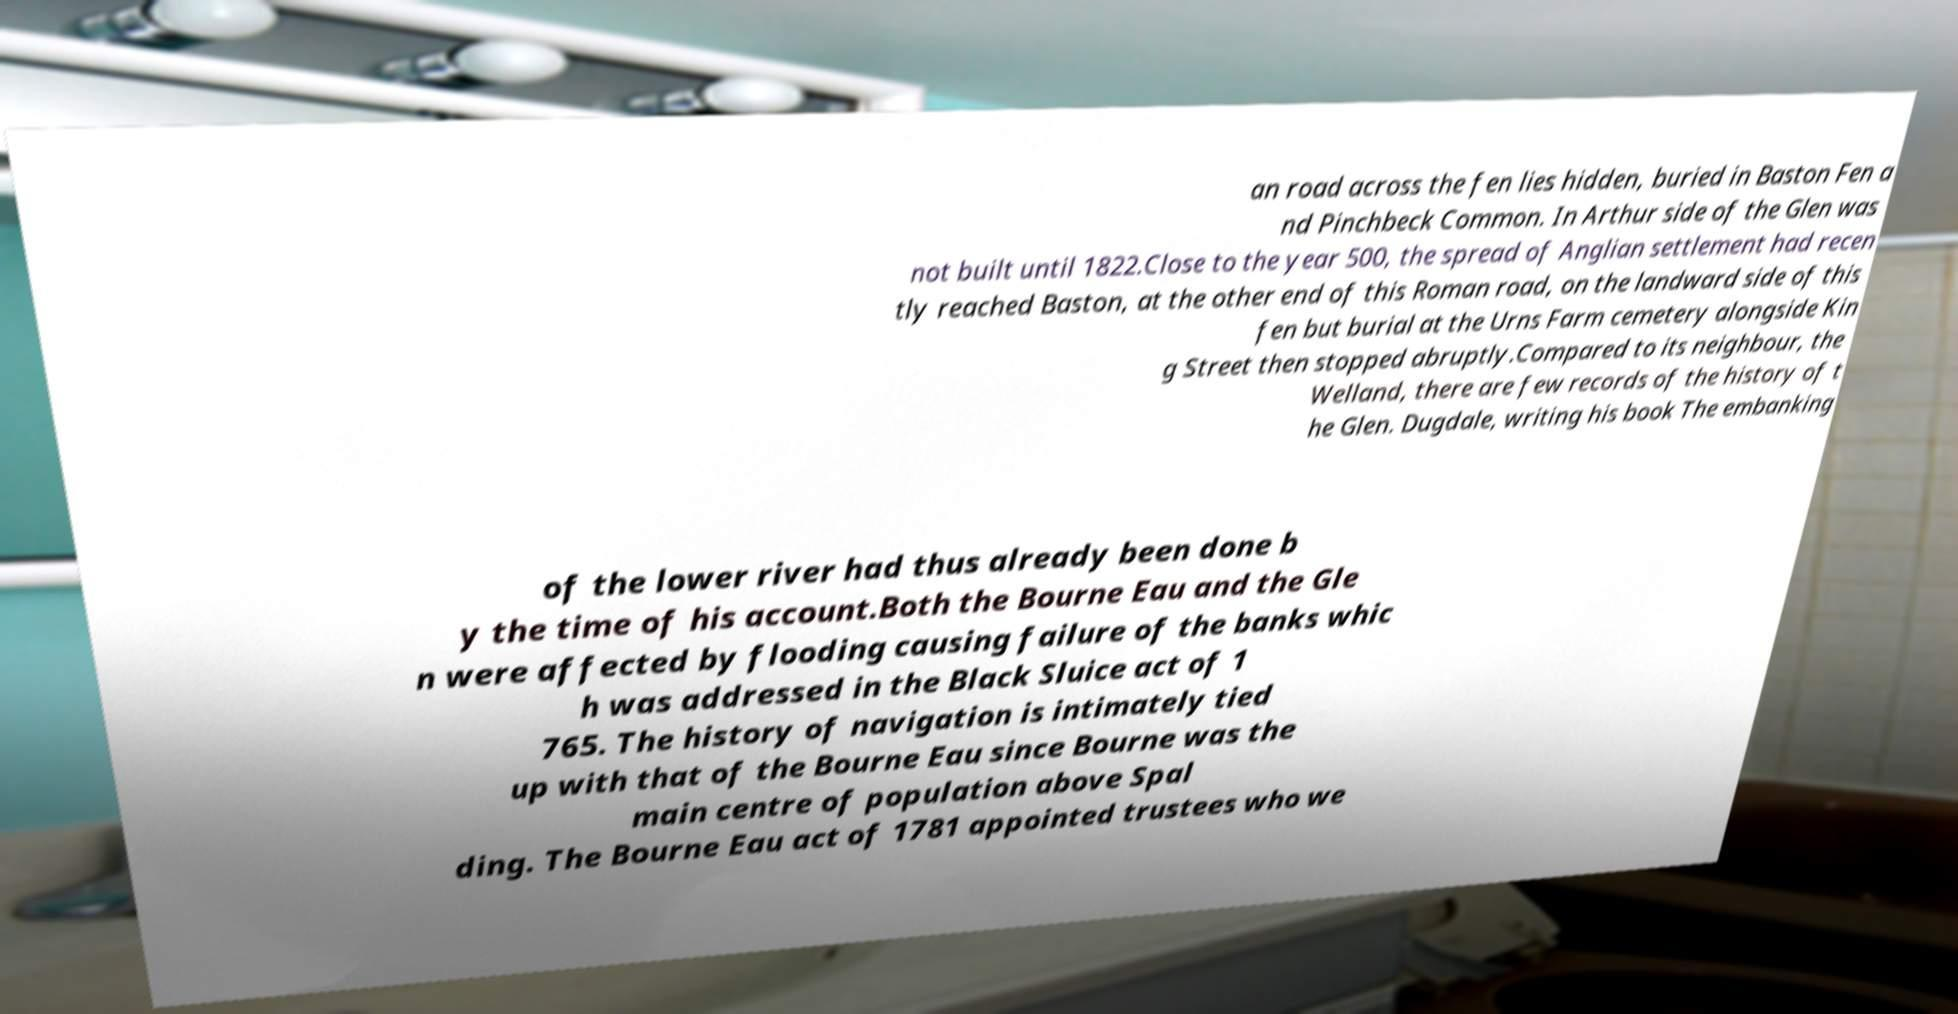There's text embedded in this image that I need extracted. Can you transcribe it verbatim? an road across the fen lies hidden, buried in Baston Fen a nd Pinchbeck Common. In Arthur side of the Glen was not built until 1822.Close to the year 500, the spread of Anglian settlement had recen tly reached Baston, at the other end of this Roman road, on the landward side of this fen but burial at the Urns Farm cemetery alongside Kin g Street then stopped abruptly.Compared to its neighbour, the Welland, there are few records of the history of t he Glen. Dugdale, writing his book The embanking of the lower river had thus already been done b y the time of his account.Both the Bourne Eau and the Gle n were affected by flooding causing failure of the banks whic h was addressed in the Black Sluice act of 1 765. The history of navigation is intimately tied up with that of the Bourne Eau since Bourne was the main centre of population above Spal ding. The Bourne Eau act of 1781 appointed trustees who we 